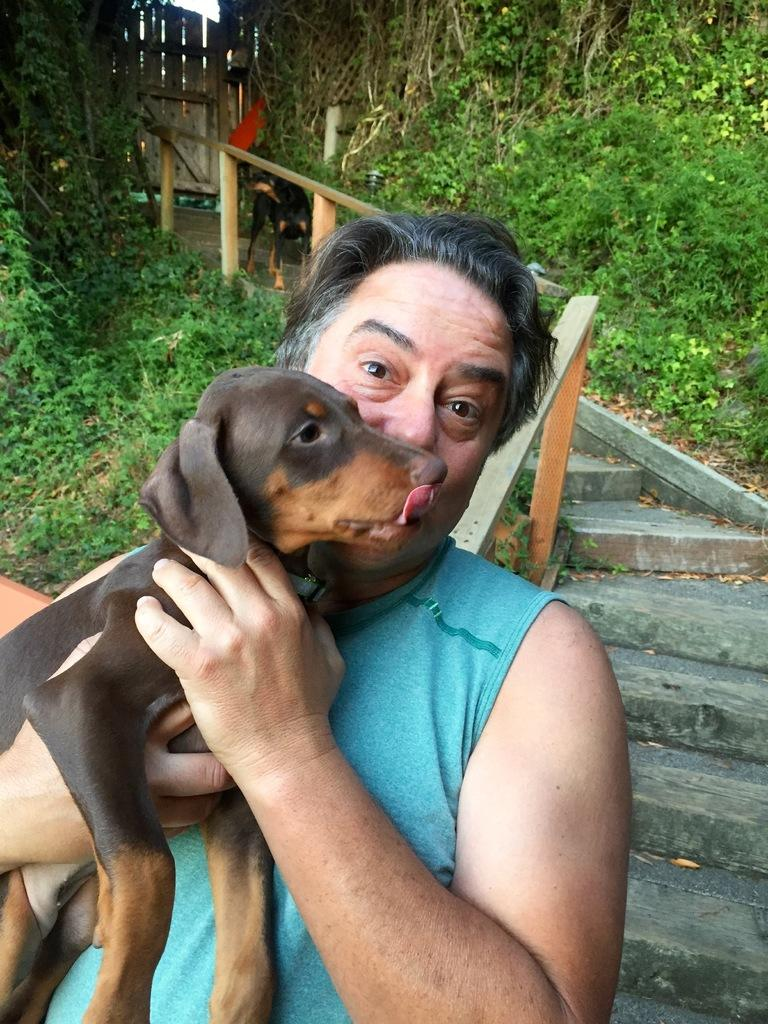Who is present in the image? There is a man in the image. What is the man holding? The man is holding a dog. What architectural feature can be seen in the image? There are stairs visible in the image. What type of vegetation is present in the image? There are plants on the sides of the image. What type of wave can be seen crashing against the buildings in the image? There is no wave present in the image; it does not depict a coastal or beach setting. 